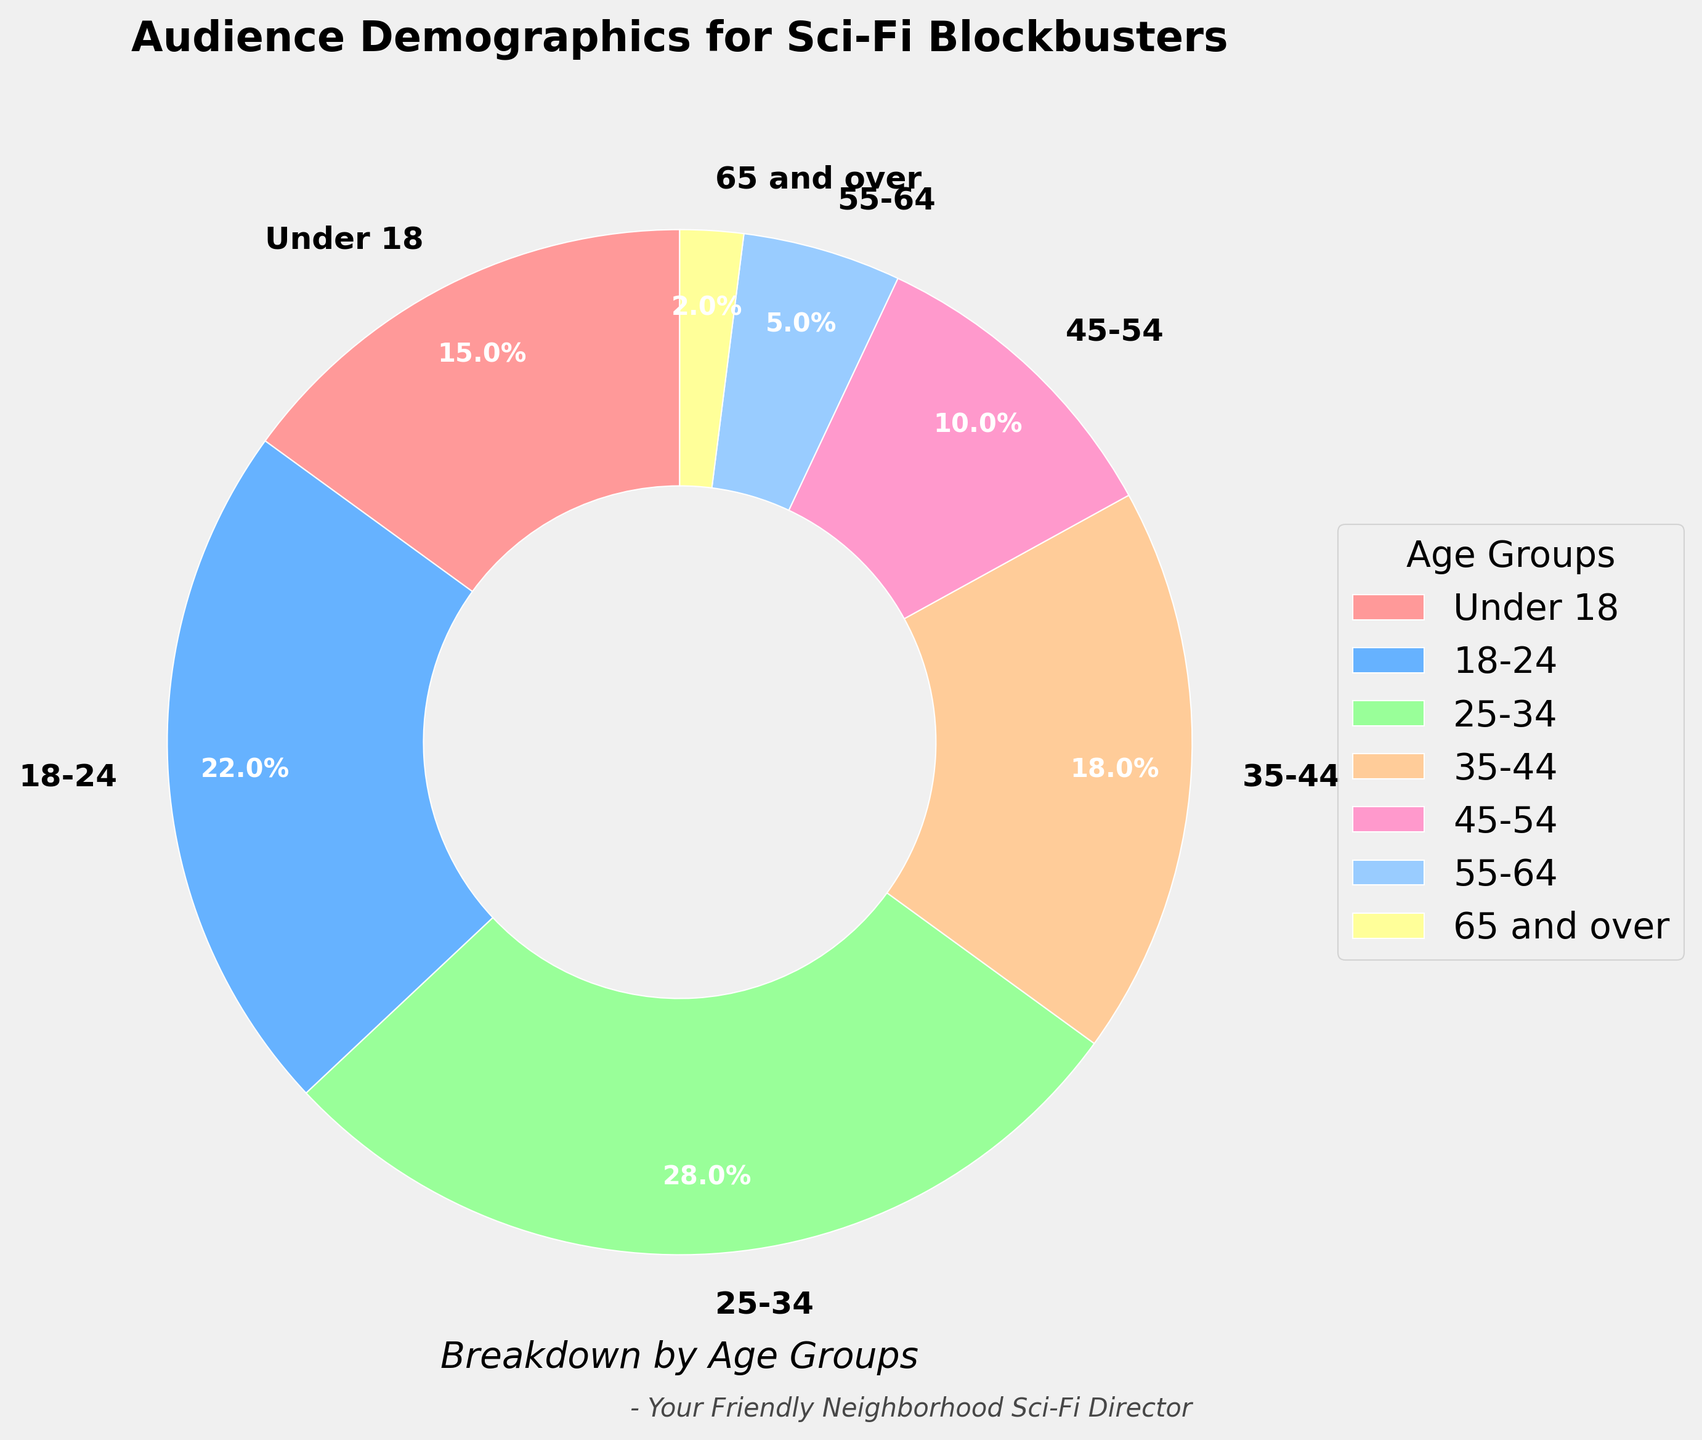Which age group makes up the largest percentage of the audience? The largest segment of the chart represents the age group 25-34, which has the highest percentage at 28%.
Answer: 25-34 How many age groups have a percentage of 10% or less? From the chart, the age groups 45-54, 55-64, and 65 and over have percentages of 10%, 5%, and 2%, respectively. Summing these up, there are three such groups.
Answer: 3 Which age group has exactly half the percentage of the largest age group? The largest age group (25-34) has 28%. Half of 28% is 14%. The age group under 18 is close but slightly higher at 15%.
Answer: Under 18 What is the combined percentage of the audience aged 35 and over? Adding the percentages: 18% (35-44) + 10% (45-54) + 5% (55-64) + 2% (65 and over) gives a total of 35%.
Answer: 35% What is the difference in percentage between the 18-24 and 35-44 age groups? The percentage of the 18-24 group is 22%, and the 35-44 group is 18%. The difference between 22% and 18% is 4%.
Answer: 4% Which two age groups together make up nearly half the total percentage? Adding the largest two age groups: 25-34 (28%) + 18-24 (22%), gives a total of 50%, which is nearly half.
Answer: 25-34 and 18-24 Identify the portion of the audience with two similar-sized age groups and their percentages. Under 18 has 15%, and 35-44 has 18%; they are the two closest in percentage size among the groups.
Answer: Under 18 and 35-44 What percentage more is the largest age group compared to the smallest age group? The largest age group is 25-34 with 28% and the smallest is 65 and over with 2%. The difference is 28% - 2% = 26%.
Answer: 26% Which age group is represented by the green color in the pie chart? In the pie chart, the color green often corresponds to mid-range values. The 25-34 age group is 28% and typically represented with a prominent color such as green.
Answer: 25-34 What is the cumulative percentage of all groups below the 25-34 age group? Adding together under 18 (15%) and 18-24 (22%), their combined percentage is 37%.
Answer: 37% 